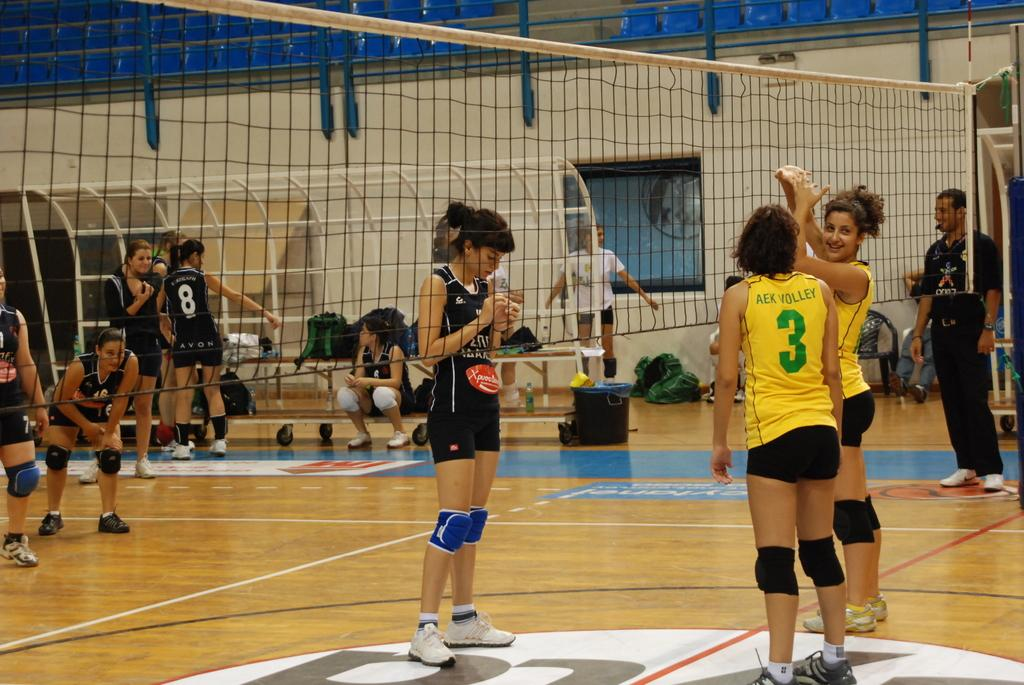Provide a one-sentence caption for the provided image. Woman wearing a yellow jersey with a number 3 on a volleyball court. 